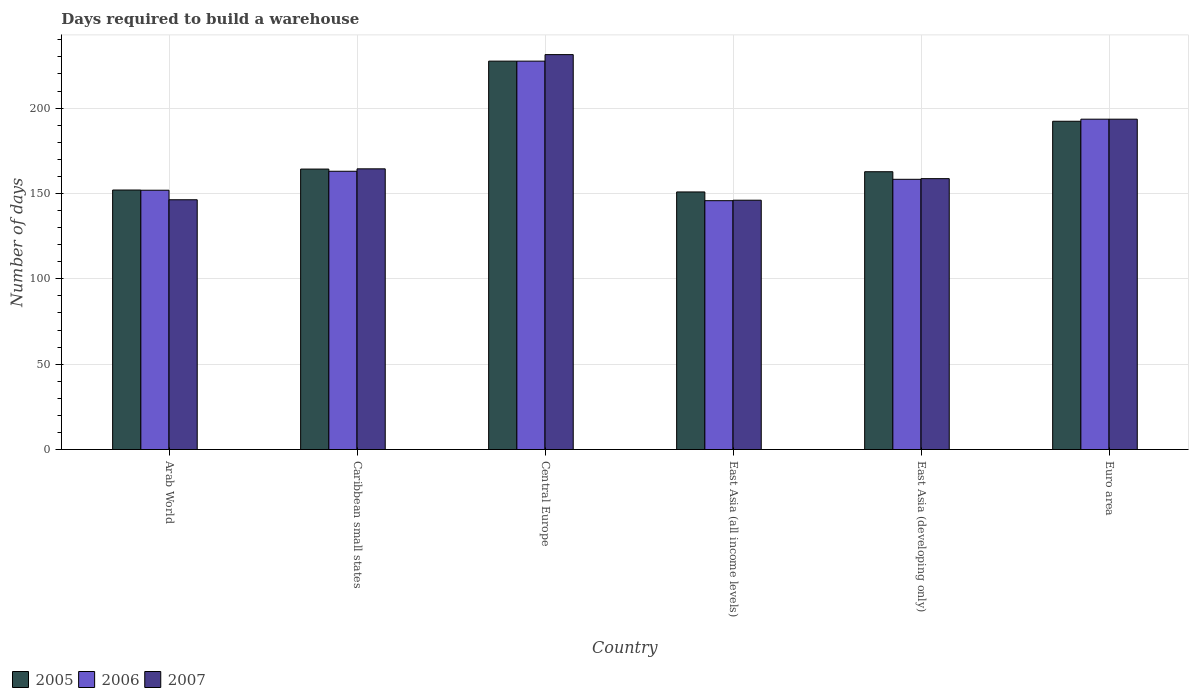How many different coloured bars are there?
Ensure brevity in your answer.  3. How many bars are there on the 4th tick from the left?
Make the answer very short. 3. What is the label of the 2nd group of bars from the left?
Provide a succinct answer. Caribbean small states. In how many cases, is the number of bars for a given country not equal to the number of legend labels?
Offer a terse response. 0. What is the days required to build a warehouse in in 2007 in Euro area?
Ensure brevity in your answer.  193.5. Across all countries, what is the maximum days required to build a warehouse in in 2006?
Make the answer very short. 227.5. Across all countries, what is the minimum days required to build a warehouse in in 2006?
Make the answer very short. 145.76. In which country was the days required to build a warehouse in in 2007 maximum?
Your answer should be compact. Central Europe. In which country was the days required to build a warehouse in in 2005 minimum?
Your response must be concise. East Asia (all income levels). What is the total days required to build a warehouse in in 2005 in the graph?
Your response must be concise. 1049.65. What is the difference between the days required to build a warehouse in in 2005 in Central Europe and that in Euro area?
Ensure brevity in your answer.  35.22. What is the difference between the days required to build a warehouse in in 2007 in Arab World and the days required to build a warehouse in in 2005 in East Asia (developing only)?
Provide a short and direct response. -16.42. What is the average days required to build a warehouse in in 2005 per country?
Your answer should be very brief. 174.94. What is the difference between the days required to build a warehouse in of/in 2007 and days required to build a warehouse in of/in 2005 in Arab World?
Give a very brief answer. -5.7. In how many countries, is the days required to build a warehouse in in 2006 greater than 60 days?
Provide a short and direct response. 6. What is the ratio of the days required to build a warehouse in in 2006 in East Asia (developing only) to that in Euro area?
Provide a succinct answer. 0.82. Is the days required to build a warehouse in in 2007 in East Asia (developing only) less than that in Euro area?
Give a very brief answer. Yes. Is the difference between the days required to build a warehouse in in 2007 in Arab World and Caribbean small states greater than the difference between the days required to build a warehouse in in 2005 in Arab World and Caribbean small states?
Offer a terse response. No. What is the difference between the highest and the second highest days required to build a warehouse in in 2005?
Your answer should be very brief. -35.22. What is the difference between the highest and the lowest days required to build a warehouse in in 2006?
Offer a very short reply. 81.74. Is the sum of the days required to build a warehouse in in 2007 in East Asia (all income levels) and Euro area greater than the maximum days required to build a warehouse in in 2005 across all countries?
Your answer should be very brief. Yes. What does the 3rd bar from the right in Central Europe represents?
Keep it short and to the point. 2005. What is the difference between two consecutive major ticks on the Y-axis?
Give a very brief answer. 50. Are the values on the major ticks of Y-axis written in scientific E-notation?
Your answer should be very brief. No. Does the graph contain grids?
Give a very brief answer. Yes. How many legend labels are there?
Ensure brevity in your answer.  3. How are the legend labels stacked?
Provide a succinct answer. Horizontal. What is the title of the graph?
Your response must be concise. Days required to build a warehouse. What is the label or title of the Y-axis?
Provide a short and direct response. Number of days. What is the Number of days of 2005 in Arab World?
Keep it short and to the point. 152. What is the Number of days in 2006 in Arab World?
Keep it short and to the point. 151.89. What is the Number of days of 2007 in Arab World?
Your response must be concise. 146.3. What is the Number of days of 2005 in Caribbean small states?
Your response must be concise. 164.27. What is the Number of days of 2006 in Caribbean small states?
Provide a short and direct response. 163. What is the Number of days of 2007 in Caribbean small states?
Make the answer very short. 164.42. What is the Number of days in 2005 in Central Europe?
Make the answer very short. 227.5. What is the Number of days in 2006 in Central Europe?
Give a very brief answer. 227.5. What is the Number of days of 2007 in Central Europe?
Offer a very short reply. 231.32. What is the Number of days of 2005 in East Asia (all income levels)?
Keep it short and to the point. 150.88. What is the Number of days in 2006 in East Asia (all income levels)?
Your answer should be compact. 145.76. What is the Number of days of 2007 in East Asia (all income levels)?
Ensure brevity in your answer.  146.04. What is the Number of days in 2005 in East Asia (developing only)?
Your answer should be very brief. 162.72. What is the Number of days of 2006 in East Asia (developing only)?
Your answer should be very brief. 158.28. What is the Number of days of 2007 in East Asia (developing only)?
Provide a short and direct response. 158.67. What is the Number of days in 2005 in Euro area?
Your answer should be very brief. 192.28. What is the Number of days in 2006 in Euro area?
Offer a very short reply. 193.5. What is the Number of days of 2007 in Euro area?
Give a very brief answer. 193.5. Across all countries, what is the maximum Number of days of 2005?
Offer a terse response. 227.5. Across all countries, what is the maximum Number of days of 2006?
Give a very brief answer. 227.5. Across all countries, what is the maximum Number of days of 2007?
Give a very brief answer. 231.32. Across all countries, what is the minimum Number of days of 2005?
Offer a very short reply. 150.88. Across all countries, what is the minimum Number of days of 2006?
Offer a very short reply. 145.76. Across all countries, what is the minimum Number of days in 2007?
Offer a very short reply. 146.04. What is the total Number of days in 2005 in the graph?
Offer a very short reply. 1049.65. What is the total Number of days in 2006 in the graph?
Your response must be concise. 1039.93. What is the total Number of days in 2007 in the graph?
Your answer should be compact. 1040.24. What is the difference between the Number of days in 2005 in Arab World and that in Caribbean small states?
Offer a very short reply. -12.27. What is the difference between the Number of days of 2006 in Arab World and that in Caribbean small states?
Keep it short and to the point. -11.11. What is the difference between the Number of days of 2007 in Arab World and that in Caribbean small states?
Provide a short and direct response. -18.12. What is the difference between the Number of days in 2005 in Arab World and that in Central Europe?
Give a very brief answer. -75.5. What is the difference between the Number of days of 2006 in Arab World and that in Central Europe?
Offer a very short reply. -75.61. What is the difference between the Number of days in 2007 in Arab World and that in Central Europe?
Ensure brevity in your answer.  -85.02. What is the difference between the Number of days of 2005 in Arab World and that in East Asia (all income levels)?
Give a very brief answer. 1.12. What is the difference between the Number of days of 2006 in Arab World and that in East Asia (all income levels)?
Offer a terse response. 6.13. What is the difference between the Number of days of 2007 in Arab World and that in East Asia (all income levels)?
Ensure brevity in your answer.  0.26. What is the difference between the Number of days in 2005 in Arab World and that in East Asia (developing only)?
Give a very brief answer. -10.72. What is the difference between the Number of days in 2006 in Arab World and that in East Asia (developing only)?
Make the answer very short. -6.39. What is the difference between the Number of days of 2007 in Arab World and that in East Asia (developing only)?
Make the answer very short. -12.37. What is the difference between the Number of days in 2005 in Arab World and that in Euro area?
Keep it short and to the point. -40.28. What is the difference between the Number of days of 2006 in Arab World and that in Euro area?
Make the answer very short. -41.61. What is the difference between the Number of days of 2007 in Arab World and that in Euro area?
Offer a very short reply. -47.2. What is the difference between the Number of days in 2005 in Caribbean small states and that in Central Europe?
Ensure brevity in your answer.  -63.23. What is the difference between the Number of days of 2006 in Caribbean small states and that in Central Europe?
Make the answer very short. -64.5. What is the difference between the Number of days of 2007 in Caribbean small states and that in Central Europe?
Keep it short and to the point. -66.9. What is the difference between the Number of days of 2005 in Caribbean small states and that in East Asia (all income levels)?
Provide a short and direct response. 13.4. What is the difference between the Number of days in 2006 in Caribbean small states and that in East Asia (all income levels)?
Offer a terse response. 17.24. What is the difference between the Number of days in 2007 in Caribbean small states and that in East Asia (all income levels)?
Your answer should be very brief. 18.38. What is the difference between the Number of days of 2005 in Caribbean small states and that in East Asia (developing only)?
Your response must be concise. 1.55. What is the difference between the Number of days of 2006 in Caribbean small states and that in East Asia (developing only)?
Keep it short and to the point. 4.72. What is the difference between the Number of days of 2007 in Caribbean small states and that in East Asia (developing only)?
Your response must be concise. 5.75. What is the difference between the Number of days in 2005 in Caribbean small states and that in Euro area?
Your response must be concise. -28.01. What is the difference between the Number of days in 2006 in Caribbean small states and that in Euro area?
Your response must be concise. -30.5. What is the difference between the Number of days in 2007 in Caribbean small states and that in Euro area?
Provide a succinct answer. -29.08. What is the difference between the Number of days in 2005 in Central Europe and that in East Asia (all income levels)?
Provide a succinct answer. 76.62. What is the difference between the Number of days in 2006 in Central Europe and that in East Asia (all income levels)?
Give a very brief answer. 81.74. What is the difference between the Number of days in 2007 in Central Europe and that in East Asia (all income levels)?
Offer a terse response. 85.28. What is the difference between the Number of days of 2005 in Central Europe and that in East Asia (developing only)?
Your response must be concise. 64.78. What is the difference between the Number of days in 2006 in Central Europe and that in East Asia (developing only)?
Your answer should be compact. 69.22. What is the difference between the Number of days of 2007 in Central Europe and that in East Asia (developing only)?
Make the answer very short. 72.65. What is the difference between the Number of days of 2005 in Central Europe and that in Euro area?
Ensure brevity in your answer.  35.22. What is the difference between the Number of days in 2007 in Central Europe and that in Euro area?
Your answer should be very brief. 37.82. What is the difference between the Number of days of 2005 in East Asia (all income levels) and that in East Asia (developing only)?
Give a very brief answer. -11.85. What is the difference between the Number of days in 2006 in East Asia (all income levels) and that in East Asia (developing only)?
Provide a succinct answer. -12.52. What is the difference between the Number of days of 2007 in East Asia (all income levels) and that in East Asia (developing only)?
Offer a very short reply. -12.63. What is the difference between the Number of days in 2005 in East Asia (all income levels) and that in Euro area?
Make the answer very short. -41.41. What is the difference between the Number of days in 2006 in East Asia (all income levels) and that in Euro area?
Keep it short and to the point. -47.74. What is the difference between the Number of days in 2007 in East Asia (all income levels) and that in Euro area?
Your response must be concise. -47.46. What is the difference between the Number of days in 2005 in East Asia (developing only) and that in Euro area?
Provide a short and direct response. -29.56. What is the difference between the Number of days of 2006 in East Asia (developing only) and that in Euro area?
Give a very brief answer. -35.22. What is the difference between the Number of days in 2007 in East Asia (developing only) and that in Euro area?
Give a very brief answer. -34.83. What is the difference between the Number of days in 2005 in Arab World and the Number of days in 2006 in Caribbean small states?
Give a very brief answer. -11. What is the difference between the Number of days of 2005 in Arab World and the Number of days of 2007 in Caribbean small states?
Ensure brevity in your answer.  -12.42. What is the difference between the Number of days of 2006 in Arab World and the Number of days of 2007 in Caribbean small states?
Your response must be concise. -12.53. What is the difference between the Number of days of 2005 in Arab World and the Number of days of 2006 in Central Europe?
Keep it short and to the point. -75.5. What is the difference between the Number of days of 2005 in Arab World and the Number of days of 2007 in Central Europe?
Provide a short and direct response. -79.32. What is the difference between the Number of days of 2006 in Arab World and the Number of days of 2007 in Central Europe?
Offer a very short reply. -79.43. What is the difference between the Number of days in 2005 in Arab World and the Number of days in 2006 in East Asia (all income levels)?
Your answer should be compact. 6.24. What is the difference between the Number of days of 2005 in Arab World and the Number of days of 2007 in East Asia (all income levels)?
Provide a succinct answer. 5.96. What is the difference between the Number of days of 2006 in Arab World and the Number of days of 2007 in East Asia (all income levels)?
Your answer should be very brief. 5.85. What is the difference between the Number of days of 2005 in Arab World and the Number of days of 2006 in East Asia (developing only)?
Offer a terse response. -6.28. What is the difference between the Number of days in 2005 in Arab World and the Number of days in 2007 in East Asia (developing only)?
Provide a succinct answer. -6.67. What is the difference between the Number of days in 2006 in Arab World and the Number of days in 2007 in East Asia (developing only)?
Make the answer very short. -6.78. What is the difference between the Number of days in 2005 in Arab World and the Number of days in 2006 in Euro area?
Offer a terse response. -41.5. What is the difference between the Number of days of 2005 in Arab World and the Number of days of 2007 in Euro area?
Keep it short and to the point. -41.5. What is the difference between the Number of days of 2006 in Arab World and the Number of days of 2007 in Euro area?
Offer a terse response. -41.61. What is the difference between the Number of days in 2005 in Caribbean small states and the Number of days in 2006 in Central Europe?
Make the answer very short. -63.23. What is the difference between the Number of days of 2005 in Caribbean small states and the Number of days of 2007 in Central Europe?
Make the answer very short. -67.05. What is the difference between the Number of days in 2006 in Caribbean small states and the Number of days in 2007 in Central Europe?
Make the answer very short. -68.32. What is the difference between the Number of days in 2005 in Caribbean small states and the Number of days in 2006 in East Asia (all income levels)?
Keep it short and to the point. 18.51. What is the difference between the Number of days in 2005 in Caribbean small states and the Number of days in 2007 in East Asia (all income levels)?
Offer a terse response. 18.23. What is the difference between the Number of days of 2006 in Caribbean small states and the Number of days of 2007 in East Asia (all income levels)?
Keep it short and to the point. 16.96. What is the difference between the Number of days in 2005 in Caribbean small states and the Number of days in 2006 in East Asia (developing only)?
Your answer should be very brief. 5.99. What is the difference between the Number of days in 2005 in Caribbean small states and the Number of days in 2007 in East Asia (developing only)?
Offer a very short reply. 5.61. What is the difference between the Number of days in 2006 in Caribbean small states and the Number of days in 2007 in East Asia (developing only)?
Ensure brevity in your answer.  4.33. What is the difference between the Number of days in 2005 in Caribbean small states and the Number of days in 2006 in Euro area?
Give a very brief answer. -29.23. What is the difference between the Number of days of 2005 in Caribbean small states and the Number of days of 2007 in Euro area?
Your answer should be compact. -29.23. What is the difference between the Number of days in 2006 in Caribbean small states and the Number of days in 2007 in Euro area?
Give a very brief answer. -30.5. What is the difference between the Number of days in 2005 in Central Europe and the Number of days in 2006 in East Asia (all income levels)?
Ensure brevity in your answer.  81.74. What is the difference between the Number of days of 2005 in Central Europe and the Number of days of 2007 in East Asia (all income levels)?
Provide a succinct answer. 81.46. What is the difference between the Number of days of 2006 in Central Europe and the Number of days of 2007 in East Asia (all income levels)?
Keep it short and to the point. 81.46. What is the difference between the Number of days of 2005 in Central Europe and the Number of days of 2006 in East Asia (developing only)?
Offer a terse response. 69.22. What is the difference between the Number of days of 2005 in Central Europe and the Number of days of 2007 in East Asia (developing only)?
Provide a succinct answer. 68.83. What is the difference between the Number of days in 2006 in Central Europe and the Number of days in 2007 in East Asia (developing only)?
Provide a short and direct response. 68.83. What is the difference between the Number of days in 2005 in Central Europe and the Number of days in 2006 in Euro area?
Your response must be concise. 34. What is the difference between the Number of days of 2005 in East Asia (all income levels) and the Number of days of 2006 in East Asia (developing only)?
Offer a very short reply. -7.4. What is the difference between the Number of days of 2005 in East Asia (all income levels) and the Number of days of 2007 in East Asia (developing only)?
Provide a succinct answer. -7.79. What is the difference between the Number of days in 2006 in East Asia (all income levels) and the Number of days in 2007 in East Asia (developing only)?
Ensure brevity in your answer.  -12.91. What is the difference between the Number of days in 2005 in East Asia (all income levels) and the Number of days in 2006 in Euro area?
Offer a terse response. -42.62. What is the difference between the Number of days in 2005 in East Asia (all income levels) and the Number of days in 2007 in Euro area?
Your answer should be very brief. -42.62. What is the difference between the Number of days of 2006 in East Asia (all income levels) and the Number of days of 2007 in Euro area?
Offer a terse response. -47.74. What is the difference between the Number of days of 2005 in East Asia (developing only) and the Number of days of 2006 in Euro area?
Offer a terse response. -30.78. What is the difference between the Number of days of 2005 in East Asia (developing only) and the Number of days of 2007 in Euro area?
Keep it short and to the point. -30.78. What is the difference between the Number of days in 2006 in East Asia (developing only) and the Number of days in 2007 in Euro area?
Your response must be concise. -35.22. What is the average Number of days in 2005 per country?
Provide a short and direct response. 174.94. What is the average Number of days in 2006 per country?
Ensure brevity in your answer.  173.32. What is the average Number of days in 2007 per country?
Offer a terse response. 173.37. What is the difference between the Number of days of 2005 and Number of days of 2007 in Arab World?
Make the answer very short. 5.7. What is the difference between the Number of days of 2006 and Number of days of 2007 in Arab World?
Offer a terse response. 5.59. What is the difference between the Number of days of 2005 and Number of days of 2006 in Caribbean small states?
Provide a short and direct response. 1.27. What is the difference between the Number of days of 2005 and Number of days of 2007 in Caribbean small states?
Provide a succinct answer. -0.14. What is the difference between the Number of days in 2006 and Number of days in 2007 in Caribbean small states?
Ensure brevity in your answer.  -1.42. What is the difference between the Number of days in 2005 and Number of days in 2007 in Central Europe?
Offer a very short reply. -3.82. What is the difference between the Number of days of 2006 and Number of days of 2007 in Central Europe?
Your response must be concise. -3.82. What is the difference between the Number of days in 2005 and Number of days in 2006 in East Asia (all income levels)?
Provide a succinct answer. 5.12. What is the difference between the Number of days of 2005 and Number of days of 2007 in East Asia (all income levels)?
Give a very brief answer. 4.83. What is the difference between the Number of days of 2006 and Number of days of 2007 in East Asia (all income levels)?
Make the answer very short. -0.28. What is the difference between the Number of days of 2005 and Number of days of 2006 in East Asia (developing only)?
Make the answer very short. 4.44. What is the difference between the Number of days in 2005 and Number of days in 2007 in East Asia (developing only)?
Make the answer very short. 4.06. What is the difference between the Number of days in 2006 and Number of days in 2007 in East Asia (developing only)?
Provide a succinct answer. -0.39. What is the difference between the Number of days of 2005 and Number of days of 2006 in Euro area?
Ensure brevity in your answer.  -1.22. What is the difference between the Number of days in 2005 and Number of days in 2007 in Euro area?
Keep it short and to the point. -1.22. What is the ratio of the Number of days in 2005 in Arab World to that in Caribbean small states?
Your answer should be compact. 0.93. What is the ratio of the Number of days of 2006 in Arab World to that in Caribbean small states?
Your response must be concise. 0.93. What is the ratio of the Number of days in 2007 in Arab World to that in Caribbean small states?
Provide a short and direct response. 0.89. What is the ratio of the Number of days of 2005 in Arab World to that in Central Europe?
Ensure brevity in your answer.  0.67. What is the ratio of the Number of days of 2006 in Arab World to that in Central Europe?
Your answer should be very brief. 0.67. What is the ratio of the Number of days of 2007 in Arab World to that in Central Europe?
Provide a succinct answer. 0.63. What is the ratio of the Number of days of 2005 in Arab World to that in East Asia (all income levels)?
Provide a succinct answer. 1.01. What is the ratio of the Number of days in 2006 in Arab World to that in East Asia (all income levels)?
Ensure brevity in your answer.  1.04. What is the ratio of the Number of days in 2007 in Arab World to that in East Asia (all income levels)?
Provide a succinct answer. 1. What is the ratio of the Number of days of 2005 in Arab World to that in East Asia (developing only)?
Your answer should be compact. 0.93. What is the ratio of the Number of days of 2006 in Arab World to that in East Asia (developing only)?
Give a very brief answer. 0.96. What is the ratio of the Number of days of 2007 in Arab World to that in East Asia (developing only)?
Give a very brief answer. 0.92. What is the ratio of the Number of days in 2005 in Arab World to that in Euro area?
Offer a terse response. 0.79. What is the ratio of the Number of days in 2006 in Arab World to that in Euro area?
Offer a terse response. 0.79. What is the ratio of the Number of days of 2007 in Arab World to that in Euro area?
Offer a terse response. 0.76. What is the ratio of the Number of days of 2005 in Caribbean small states to that in Central Europe?
Offer a terse response. 0.72. What is the ratio of the Number of days of 2006 in Caribbean small states to that in Central Europe?
Your answer should be very brief. 0.72. What is the ratio of the Number of days of 2007 in Caribbean small states to that in Central Europe?
Provide a short and direct response. 0.71. What is the ratio of the Number of days in 2005 in Caribbean small states to that in East Asia (all income levels)?
Offer a very short reply. 1.09. What is the ratio of the Number of days of 2006 in Caribbean small states to that in East Asia (all income levels)?
Your response must be concise. 1.12. What is the ratio of the Number of days of 2007 in Caribbean small states to that in East Asia (all income levels)?
Provide a succinct answer. 1.13. What is the ratio of the Number of days of 2005 in Caribbean small states to that in East Asia (developing only)?
Keep it short and to the point. 1.01. What is the ratio of the Number of days in 2006 in Caribbean small states to that in East Asia (developing only)?
Give a very brief answer. 1.03. What is the ratio of the Number of days in 2007 in Caribbean small states to that in East Asia (developing only)?
Your answer should be very brief. 1.04. What is the ratio of the Number of days in 2005 in Caribbean small states to that in Euro area?
Offer a terse response. 0.85. What is the ratio of the Number of days in 2006 in Caribbean small states to that in Euro area?
Your response must be concise. 0.84. What is the ratio of the Number of days in 2007 in Caribbean small states to that in Euro area?
Provide a succinct answer. 0.85. What is the ratio of the Number of days in 2005 in Central Europe to that in East Asia (all income levels)?
Keep it short and to the point. 1.51. What is the ratio of the Number of days of 2006 in Central Europe to that in East Asia (all income levels)?
Give a very brief answer. 1.56. What is the ratio of the Number of days of 2007 in Central Europe to that in East Asia (all income levels)?
Provide a short and direct response. 1.58. What is the ratio of the Number of days in 2005 in Central Europe to that in East Asia (developing only)?
Your answer should be very brief. 1.4. What is the ratio of the Number of days of 2006 in Central Europe to that in East Asia (developing only)?
Your response must be concise. 1.44. What is the ratio of the Number of days of 2007 in Central Europe to that in East Asia (developing only)?
Give a very brief answer. 1.46. What is the ratio of the Number of days of 2005 in Central Europe to that in Euro area?
Provide a short and direct response. 1.18. What is the ratio of the Number of days of 2006 in Central Europe to that in Euro area?
Offer a terse response. 1.18. What is the ratio of the Number of days in 2007 in Central Europe to that in Euro area?
Your answer should be compact. 1.2. What is the ratio of the Number of days in 2005 in East Asia (all income levels) to that in East Asia (developing only)?
Offer a terse response. 0.93. What is the ratio of the Number of days of 2006 in East Asia (all income levels) to that in East Asia (developing only)?
Your answer should be compact. 0.92. What is the ratio of the Number of days of 2007 in East Asia (all income levels) to that in East Asia (developing only)?
Your answer should be compact. 0.92. What is the ratio of the Number of days of 2005 in East Asia (all income levels) to that in Euro area?
Offer a very short reply. 0.78. What is the ratio of the Number of days in 2006 in East Asia (all income levels) to that in Euro area?
Ensure brevity in your answer.  0.75. What is the ratio of the Number of days of 2007 in East Asia (all income levels) to that in Euro area?
Your answer should be compact. 0.75. What is the ratio of the Number of days in 2005 in East Asia (developing only) to that in Euro area?
Your answer should be very brief. 0.85. What is the ratio of the Number of days of 2006 in East Asia (developing only) to that in Euro area?
Ensure brevity in your answer.  0.82. What is the ratio of the Number of days of 2007 in East Asia (developing only) to that in Euro area?
Make the answer very short. 0.82. What is the difference between the highest and the second highest Number of days in 2005?
Your response must be concise. 35.22. What is the difference between the highest and the second highest Number of days of 2007?
Offer a very short reply. 37.82. What is the difference between the highest and the lowest Number of days of 2005?
Your response must be concise. 76.62. What is the difference between the highest and the lowest Number of days in 2006?
Provide a succinct answer. 81.74. What is the difference between the highest and the lowest Number of days in 2007?
Make the answer very short. 85.28. 